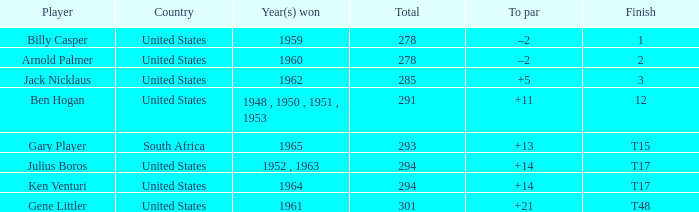What is Finish, when Country is "United States", and when To Par is "+21"? T48. 